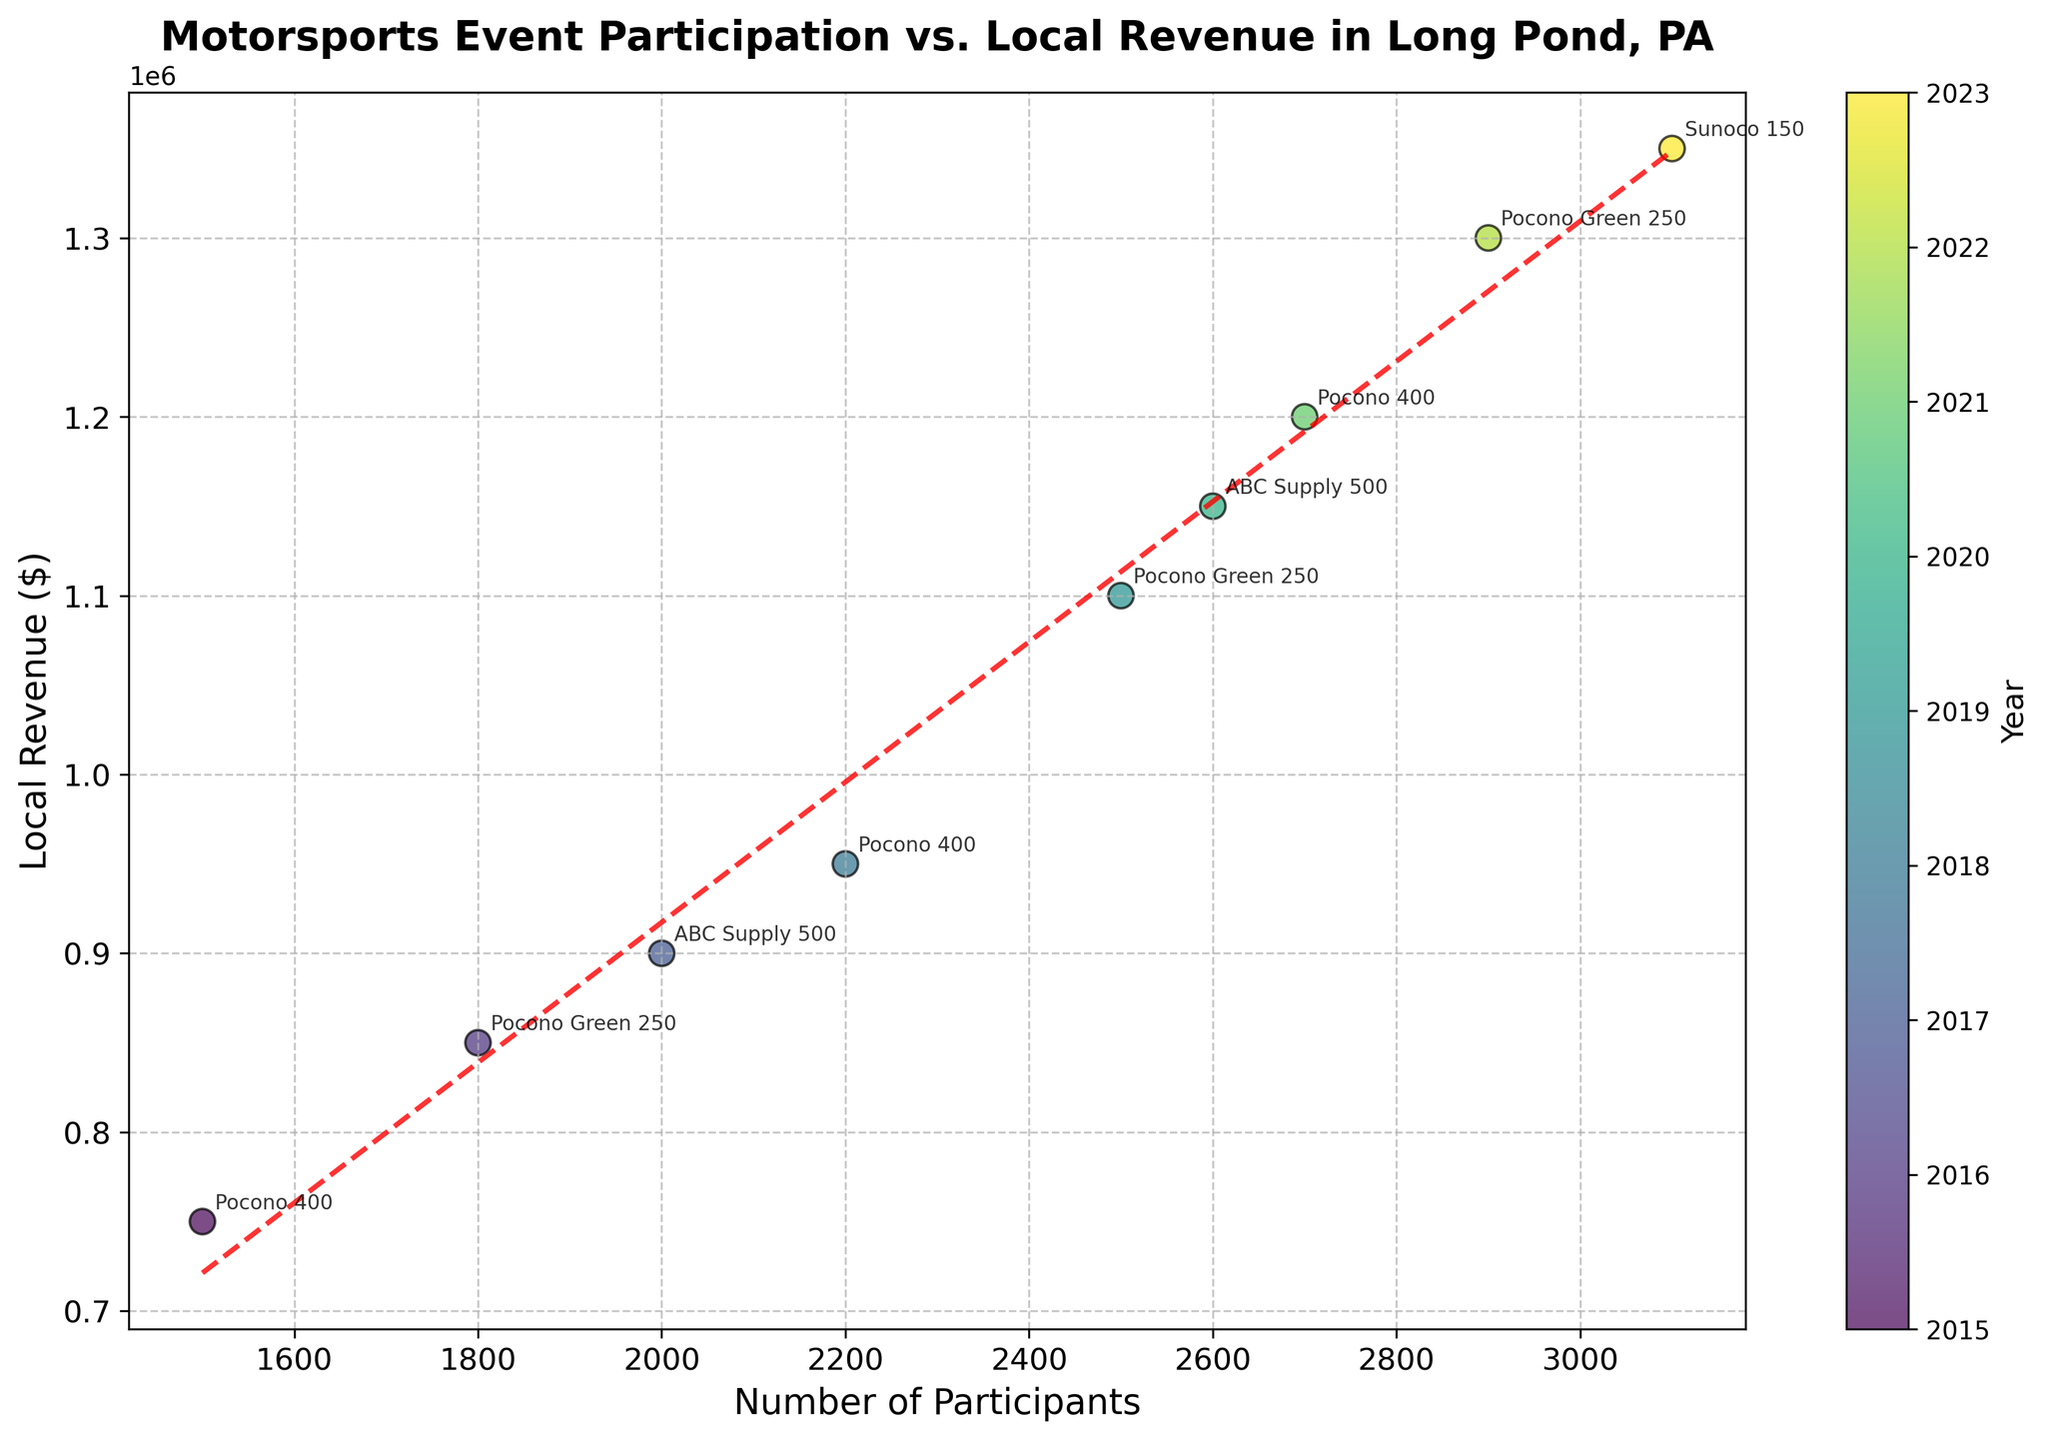What is the title of the plot? The title of the plot is usually found at the top of the figure. In this case, it reads "Motorsports Event Participation vs. Local Revenue in Long Pond, PA".
Answer: Motorsports Event Participation vs. Local Revenue in Long Pond, PA How many data points are there on the scatter plot? Count each individual scatter plot point representing a year's data for a specific event. There are 9 data points in total.
Answer: 9 What does the color of the dots represent? The color of the dots corresponds to the year of the event, with the color gradient shown in the colorbar on the right side of the figure.
Answer: Year What does the trend line suggest about the relationship between the number of participants and local revenue? The trend line shows the general direction of the data points. Here, an increasing trend line indicates a positive correlation between the number of participants and local revenue.
Answer: Positive correlation Which event had the highest number of participants? Look at the rightmost data point on the x-axis, representing the highest number of participants. The event annotated as "Sunoco 150" has the highest number of participants at 3100.
Answer: Sunoco 150 How much local revenue was generated in 2020? Identify the data point corresponding to the year 2020 using the color scale and annotations. The local revenue for 2020 (ABC Supply 500) was $1,150,000.
Answer: $1,150,000 What is the local revenue for the Pocono Green 250 in 2019 compared to the Sunoco 150 in 2023? Locate the data points for Pocono Green 250 (2019), which had a revenue of $1,100,000, and Sunoco 150 (2023), which had a revenue of $1,350,000. Comparing these values shows that the Sunoco 150 in 2023 generated more revenue.
Answer: Sunoco 150 generated $250,000 more revenue Based on the trend line, if a future event had 3500 participants, what would the approximate local revenue be? Extend the trend line visually or use the equation of the trend line to estimate the local revenue. Assume the trend continues, the local revenue for 3500 participants would likely fall around $1,500,000.
Answer: Approximately $1,500,000 Which event took place in the year with the highest local revenue? Refer to the color scale and find the data point with the highest y-value. The event in 2023 (Sunoco 150) had the highest local revenue at $1,350,000.
Answer: Sunoco 150 Between 2015 and 2023, which year showed the greatest increase in local revenue compared to the previous year? Calculate the change in local revenue year-over-year and identify the greatest increase. The change from 2018 ($950,000) to 2019 ($1,100,000) shows an increase of $150,000, which is the largest.
Answer: 2019 